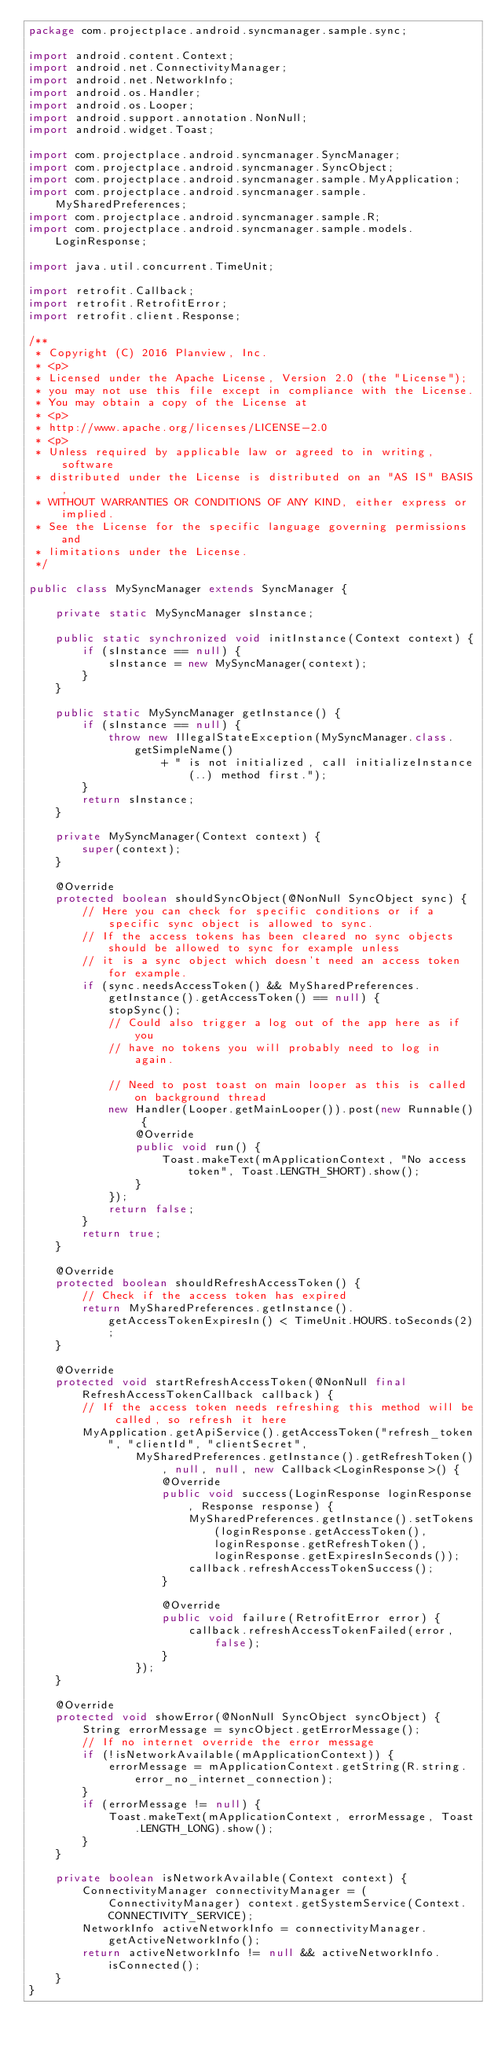<code> <loc_0><loc_0><loc_500><loc_500><_Java_>package com.projectplace.android.syncmanager.sample.sync;

import android.content.Context;
import android.net.ConnectivityManager;
import android.net.NetworkInfo;
import android.os.Handler;
import android.os.Looper;
import android.support.annotation.NonNull;
import android.widget.Toast;

import com.projectplace.android.syncmanager.SyncManager;
import com.projectplace.android.syncmanager.SyncObject;
import com.projectplace.android.syncmanager.sample.MyApplication;
import com.projectplace.android.syncmanager.sample.MySharedPreferences;
import com.projectplace.android.syncmanager.sample.R;
import com.projectplace.android.syncmanager.sample.models.LoginResponse;

import java.util.concurrent.TimeUnit;

import retrofit.Callback;
import retrofit.RetrofitError;
import retrofit.client.Response;

/**
 * Copyright (C) 2016 Planview, Inc.
 * <p>
 * Licensed under the Apache License, Version 2.0 (the "License");
 * you may not use this file except in compliance with the License.
 * You may obtain a copy of the License at
 * <p>
 * http://www.apache.org/licenses/LICENSE-2.0
 * <p>
 * Unless required by applicable law or agreed to in writing, software
 * distributed under the License is distributed on an "AS IS" BASIS,
 * WITHOUT WARRANTIES OR CONDITIONS OF ANY KIND, either express or implied.
 * See the License for the specific language governing permissions and
 * limitations under the License.
 */

public class MySyncManager extends SyncManager {

    private static MySyncManager sInstance;

    public static synchronized void initInstance(Context context) {
        if (sInstance == null) {
            sInstance = new MySyncManager(context);
        }
    }

    public static MySyncManager getInstance() {
        if (sInstance == null) {
            throw new IllegalStateException(MySyncManager.class.getSimpleName()
                    + " is not initialized, call initializeInstance(..) method first.");
        }
        return sInstance;
    }

    private MySyncManager(Context context) {
        super(context);
    }

    @Override
    protected boolean shouldSyncObject(@NonNull SyncObject sync) {
        // Here you can check for specific conditions or if a specific sync object is allowed to sync.
        // If the access tokens has been cleared no sync objects should be allowed to sync for example unless
        // it is a sync object which doesn't need an access token for example.
        if (sync.needsAccessToken() && MySharedPreferences.getInstance().getAccessToken() == null) {
            stopSync();
            // Could also trigger a log out of the app here as if you
            // have no tokens you will probably need to log in again.

            // Need to post toast on main looper as this is called on background thread
            new Handler(Looper.getMainLooper()).post(new Runnable() {
                @Override
                public void run() {
                    Toast.makeText(mApplicationContext, "No access token", Toast.LENGTH_SHORT).show();
                }
            });
            return false;
        }
        return true;
    }

    @Override
    protected boolean shouldRefreshAccessToken() {
        // Check if the access token has expired
        return MySharedPreferences.getInstance().getAccessTokenExpiresIn() < TimeUnit.HOURS.toSeconds(2);
    }

    @Override
    protected void startRefreshAccessToken(@NonNull final RefreshAccessTokenCallback callback) {
        // If the access token needs refreshing this method will be called, so refresh it here
        MyApplication.getApiService().getAccessToken("refresh_token", "clientId", "clientSecret",
                MySharedPreferences.getInstance().getRefreshToken(), null, null, new Callback<LoginResponse>() {
                    @Override
                    public void success(LoginResponse loginResponse, Response response) {
                        MySharedPreferences.getInstance().setTokens(loginResponse.getAccessToken(), loginResponse.getRefreshToken(), loginResponse.getExpiresInSeconds());
                        callback.refreshAccessTokenSuccess();
                    }

                    @Override
                    public void failure(RetrofitError error) {
                        callback.refreshAccessTokenFailed(error, false);
                    }
                });
    }

    @Override
    protected void showError(@NonNull SyncObject syncObject) {
        String errorMessage = syncObject.getErrorMessage();
        // If no internet override the error message
        if (!isNetworkAvailable(mApplicationContext)) {
            errorMessage = mApplicationContext.getString(R.string.error_no_internet_connection);
        }
        if (errorMessage != null) {
            Toast.makeText(mApplicationContext, errorMessage, Toast.LENGTH_LONG).show();
        }
    }

    private boolean isNetworkAvailable(Context context) {
        ConnectivityManager connectivityManager = (ConnectivityManager) context.getSystemService(Context.CONNECTIVITY_SERVICE);
        NetworkInfo activeNetworkInfo = connectivityManager.getActiveNetworkInfo();
        return activeNetworkInfo != null && activeNetworkInfo.isConnected();
    }
}
</code> 